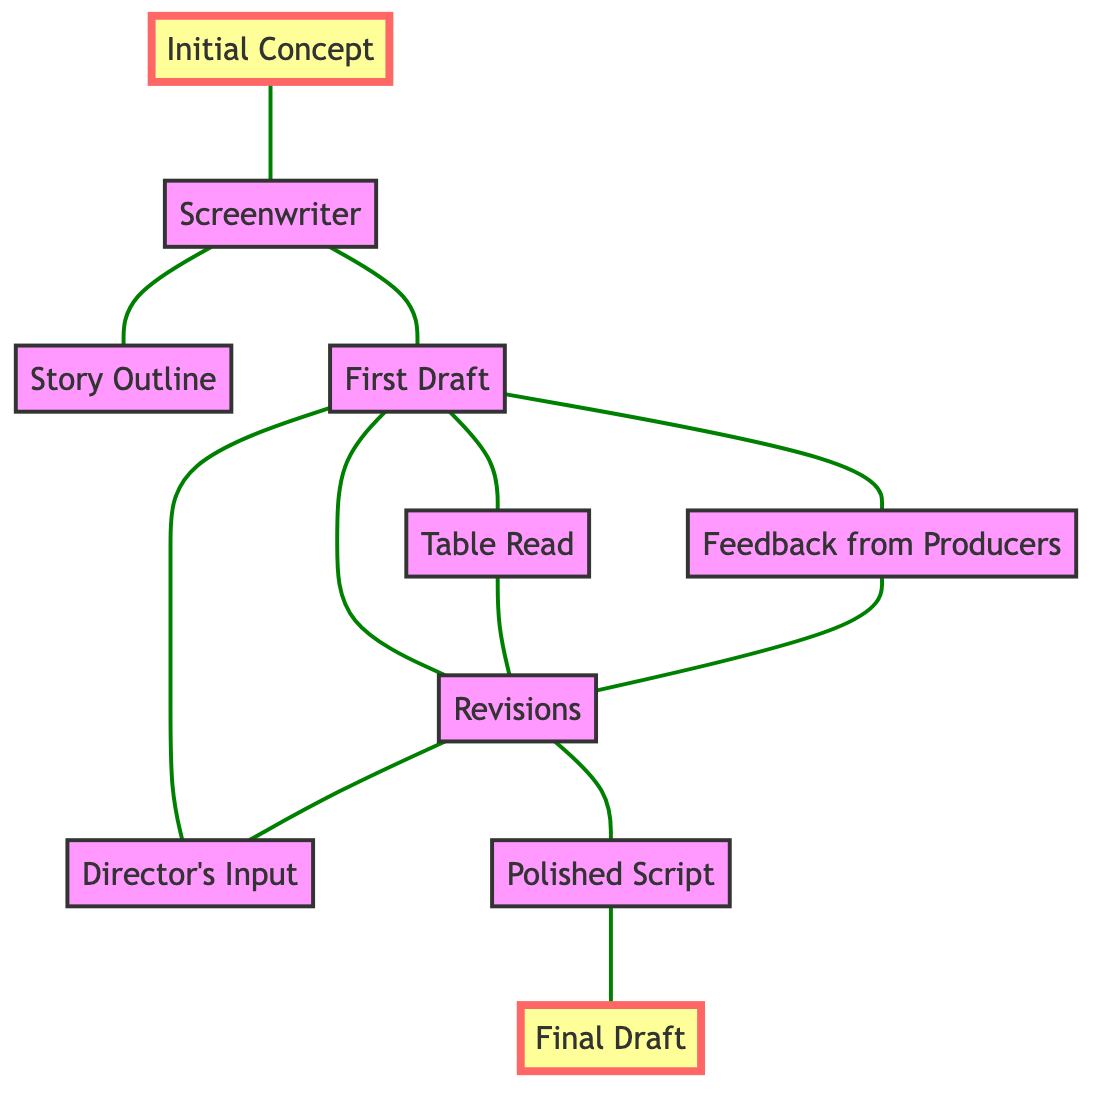What is the starting point of the screenplay evolution? The diagram shows that the starting point is "Initial Concept" which is linked to "Screenwriter". This indicates that the process begins with a basic idea.
Answer: Initial Concept How many nodes are in the diagram? The diagram lists 10 specific contributions or stages in screenplay evolution, recognized as distinct nodes. Thus, counting those, there are 10 nodes.
Answer: 10 Who provides feedback after the first draft? The first draft connects directly to "Feedback from Producers", indicating that producers are responsible for giving feedback at this stage.
Answer: Producers What is the final document produced at the end of the process? The end of the diagram shows a direct link to "Final Draft" from "Polished Script", which indicates that this is the final output of the screenplay evolution process.
Answer: Final Draft How many edges are present in the diagram? The diagram contains 11 edges, representing the connections or transitions between the different nodes illustrating the workflow of contributions to the screenplay.
Answer: 11 Which stage comes after "Revisions"? Looking at the connections from the "Revisions" node, it leads to "First Draft" and "Directed's Input", but it also leads to "Polished Script". This shows that the next significant stage after revisions is "Polished Script".
Answer: Polished Script What stage involves a reading of the screenplay? The connection from "First Draft" to "Table Read" indicates that this stage involves an actual reading of the screenplay for evaluation and feedback.
Answer: Table Read How does the director contribute to the screenplay process? The diagram shows that "Director's Input" connects to "Revisions", indicating that the director contributes by providing input during the revisions stage of the screenplay.
Answer: Revisions Which node is directly linked to the "Story Outline"? The "Story Outline" has a direct connection from "Screenwriter" which indicates that the screenwriter is responsible for creating the story outline from the initial concept.
Answer: Screenwriter 